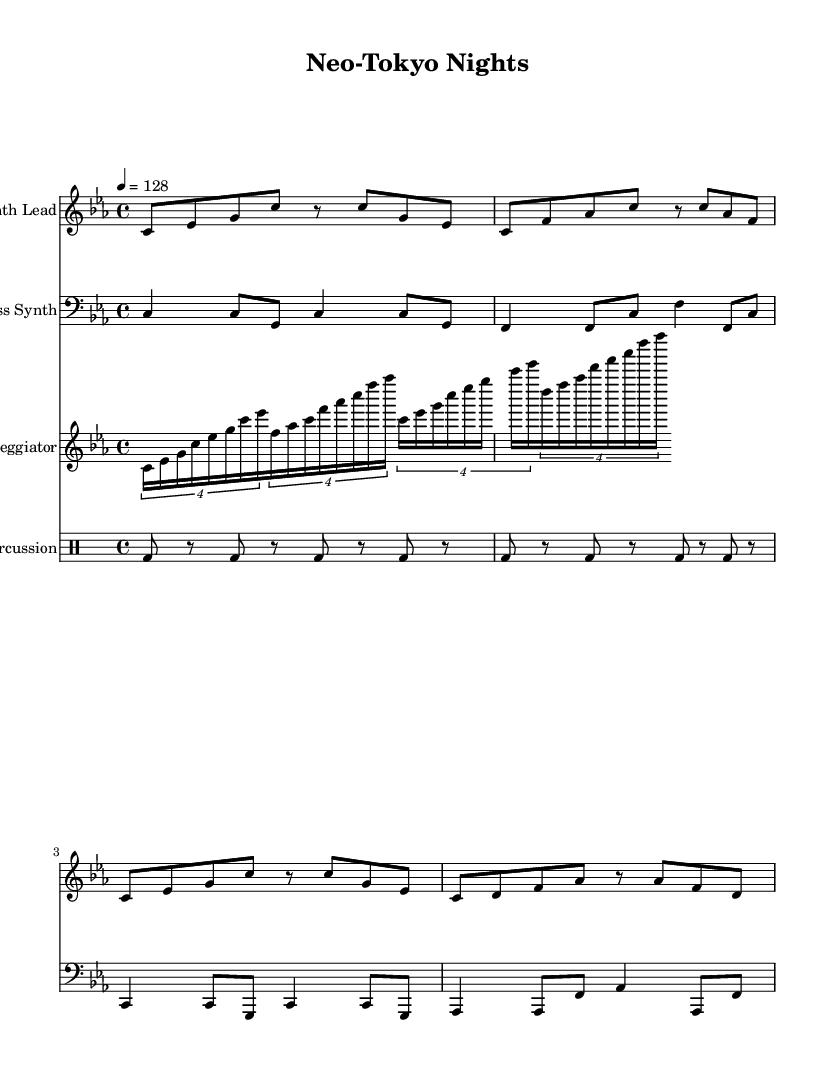What is the key signature of this music? The key signature is C minor, which has three flats (B-flat, E-flat, and A-flat). This is indicated at the beginning of the staff where the flats are shown.
Answer: C minor What is the time signature of this piece? The time signature is 4/4, which means there are four beats in each measure and the quarter note receives one beat. This is indicated at the start of the music, right next to the key signature.
Answer: 4/4 What is the tempo marking of this composition? The tempo marking states "4 = 128," meaning that a quarter note (4) should be played at a speed of 128 beats per minute. This is located at the beginning of the score.
Answer: 128 How many measures are in the Synth Lead part? The Synth Lead part contains four measures, as evidenced by counting the measure bars across the staff. Each section is marked by a vertical line indicating the end of a measure.
Answer: 4 What note does the Bass Synth start on? The Bass Synth starts on the note C. This is the first note in the Bass Synth staff and is clearly shown as the lowest note in the staff.
Answer: C What type of synthesizer sound is primarily featured in this piece? The piece primarily features a synth lead, indicated by the labeled staff "Synth Lead" at the top. This label clarifies the main instrument sound used in the music.
Answer: Synth Lead How does the arpeggiator rhythmically relate to the other parts? The arpeggiator uses tuplets and plays 16th notes, creating a faster rhythmic texture that often complements the slower rhythmic figures of the other parts. The tuplet markings show the grouping of notes, indicating a distinct rhythmic layering.
Answer: Faster texture 